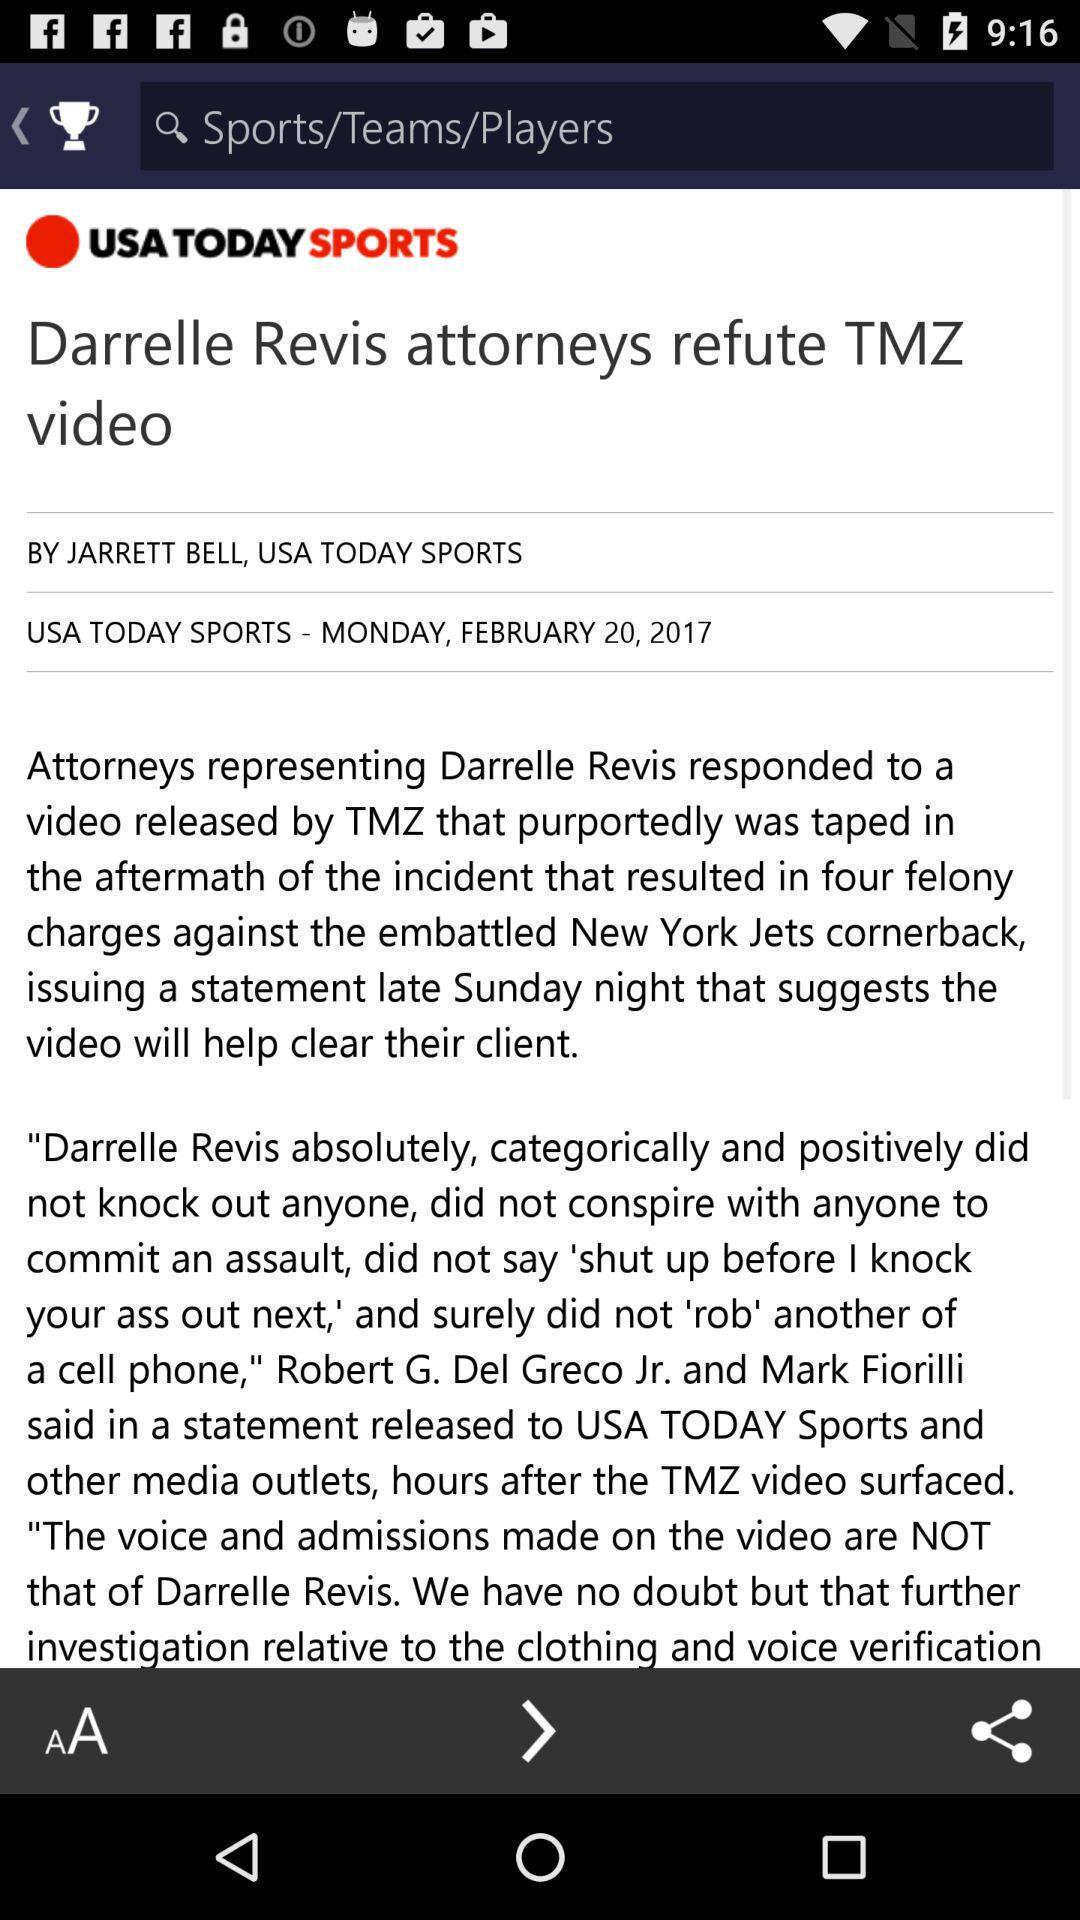What is the author name? The author's name is "JARRETT BELL". 